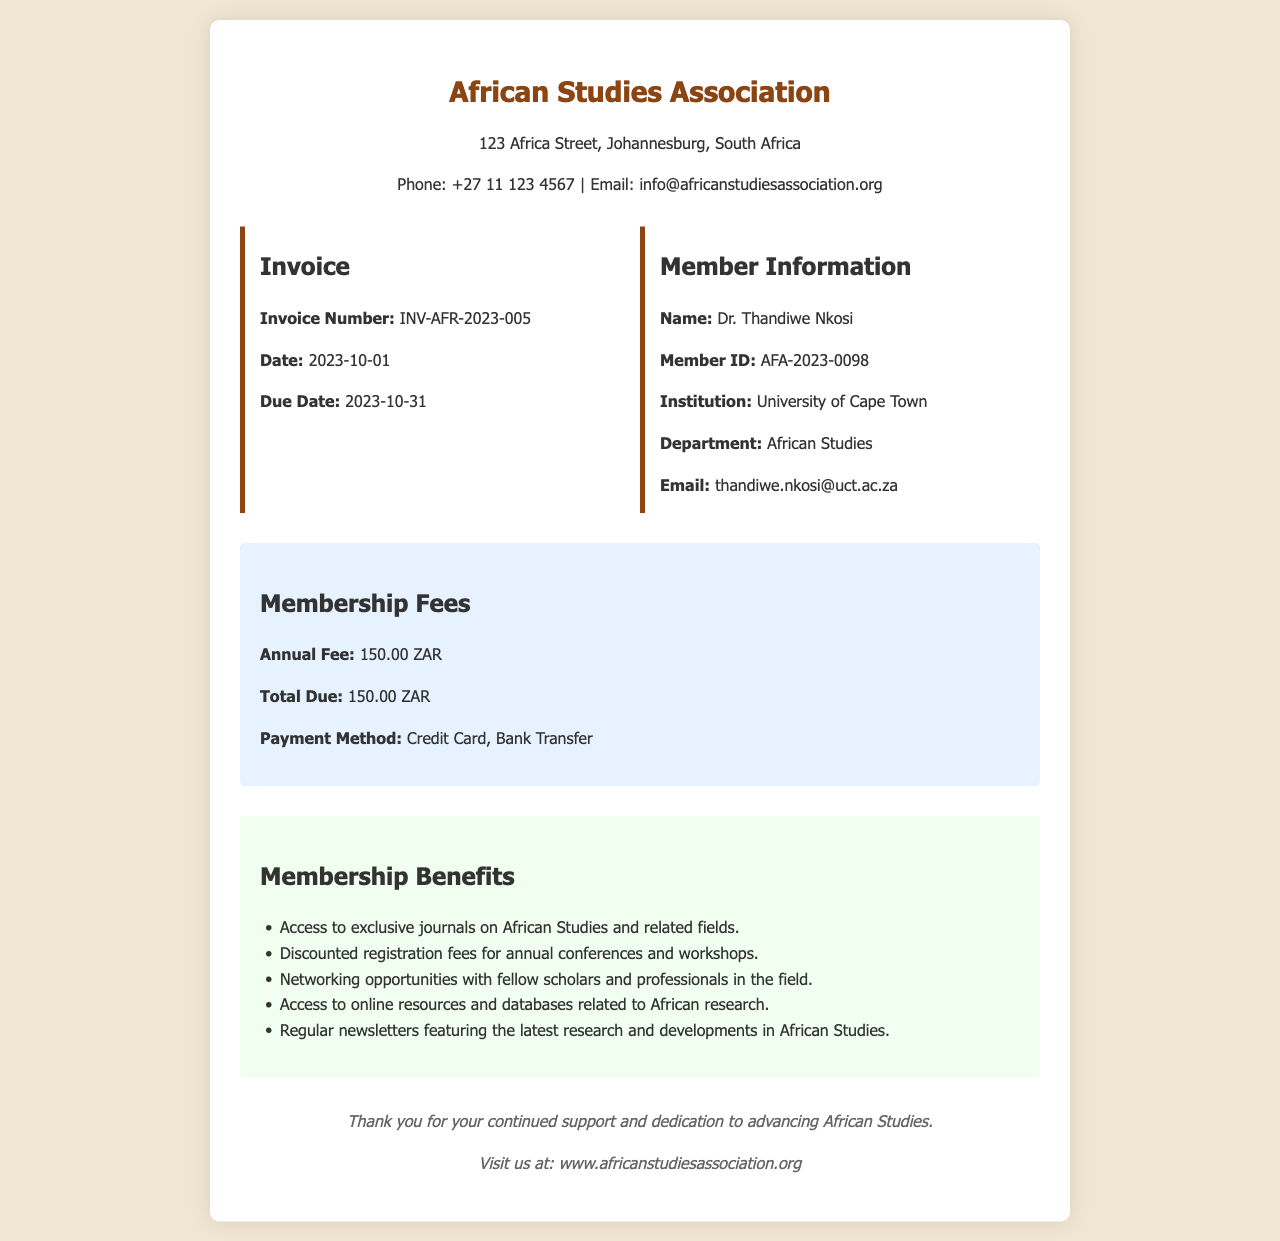What is the name of the member? The member's name is directly stated in the document under the 'Member Information' section.
Answer: Dr. Thandiwe Nkosi What is the total due amount? The total due amount is specified clearly in the 'Membership Fees' section of the document.
Answer: 150.00 ZAR When is the due date for the invoice? The due date is mentioned in the 'Invoice' section, providing a specific deadline.
Answer: 2023-10-31 What is the invoice number? The invoice number is located at the beginning of the document within the 'Invoice' section.
Answer: INV-AFR-2023-005 What payment methods are accepted? The acceptable payment methods are listed in the 'Membership Fees' section of the document.
Answer: Credit Card, Bank Transfer How much is the annual fee? The annual fee is featured prominently in the 'Membership Fees' section.
Answer: 150.00 ZAR What institution is Dr. Thandiwe Nkosi affiliated with? The institution name is provided in the 'Member Information' part of the document.
Answer: University of Cape Town List one benefit of membership. The benefits of membership are enumerated in the 'Membership Benefits' section, allowing for easy retrieval of information.
Answer: Access to exclusive journals on African Studies and related fields How many benefits are listed in the document? The total number of benefits can be counted from the bulleted list in the 'Membership Benefits' section.
Answer: Five 